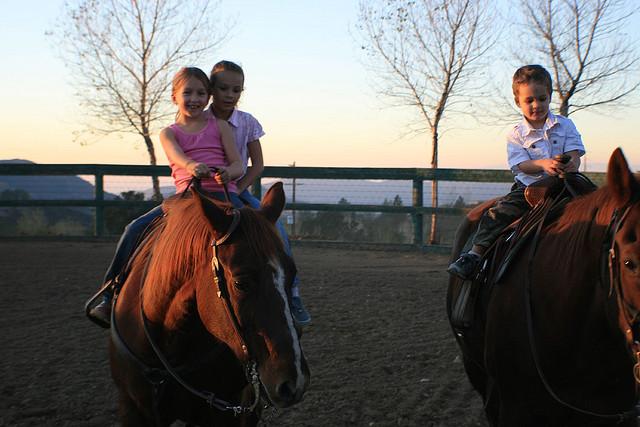How many are on the left horse?
Short answer required. 2. What 2 colors is the horse?
Answer briefly. Brown and white. Is there a white car in the background?
Quick response, please. No. What are these men's jobs?
Quick response, please. Horse training. What is the animal wearing?
Short answer required. Saddle. What type of footwear does the rider wear?
Keep it brief. Shoes. What are these people riding?
Be succinct. Horses. Are these horses in a meadow?
Quick response, please. No. How many kids are there?
Quick response, please. 3. 